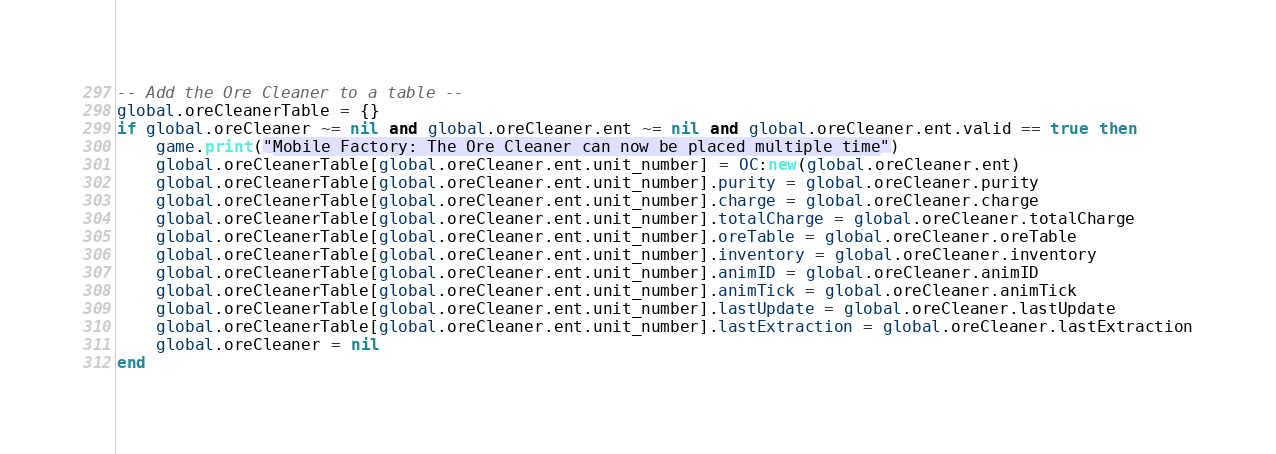Convert code to text. <code><loc_0><loc_0><loc_500><loc_500><_Lua_>-- Add the Ore Cleaner to a table --
global.oreCleanerTable = {}
if global.oreCleaner ~= nil and global.oreCleaner.ent ~= nil and global.oreCleaner.ent.valid == true then
	game.print("Mobile Factory: The Ore Cleaner can now be placed multiple time")
	global.oreCleanerTable[global.oreCleaner.ent.unit_number] = OC:new(global.oreCleaner.ent)
	global.oreCleanerTable[global.oreCleaner.ent.unit_number].purity = global.oreCleaner.purity
	global.oreCleanerTable[global.oreCleaner.ent.unit_number].charge = global.oreCleaner.charge
	global.oreCleanerTable[global.oreCleaner.ent.unit_number].totalCharge = global.oreCleaner.totalCharge
	global.oreCleanerTable[global.oreCleaner.ent.unit_number].oreTable = global.oreCleaner.oreTable
	global.oreCleanerTable[global.oreCleaner.ent.unit_number].inventory = global.oreCleaner.inventory
	global.oreCleanerTable[global.oreCleaner.ent.unit_number].animID = global.oreCleaner.animID
	global.oreCleanerTable[global.oreCleaner.ent.unit_number].animTick = global.oreCleaner.animTick
	global.oreCleanerTable[global.oreCleaner.ent.unit_number].lastUpdate = global.oreCleaner.lastUpdate
	global.oreCleanerTable[global.oreCleaner.ent.unit_number].lastExtraction = global.oreCleaner.lastExtraction
	global.oreCleaner = nil
end</code> 